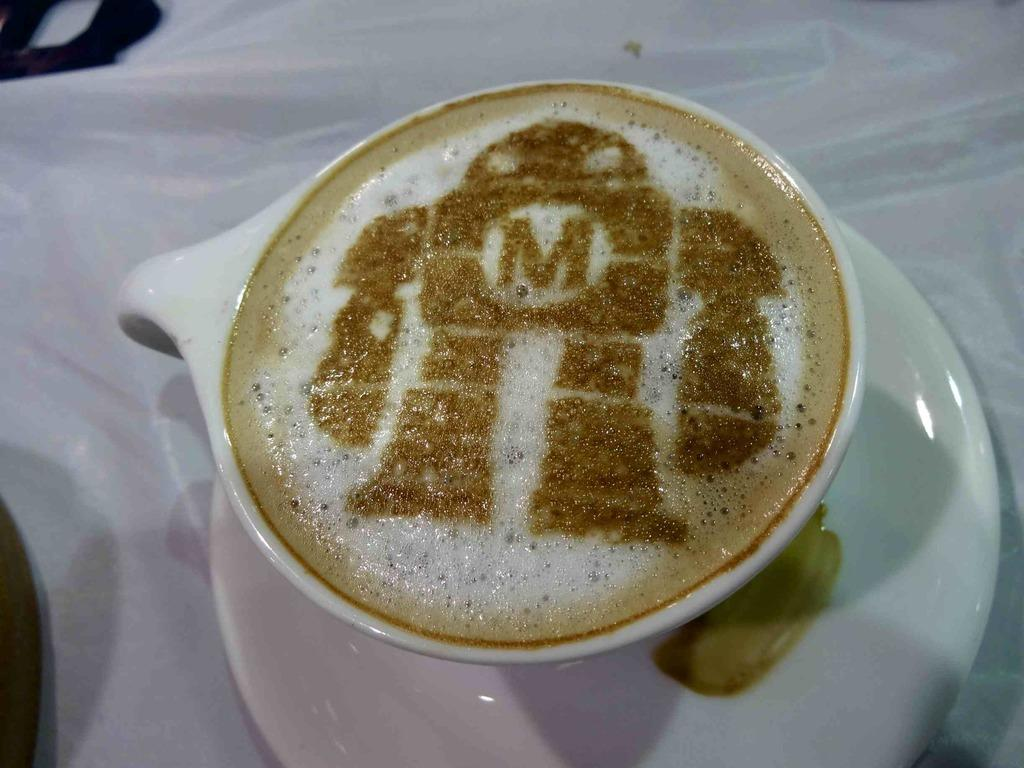What is the primary substance in the image? There is a liquid in the image. Can you describe the unique letter in the image? There is a letter in the shape of a person in a cup. What other objects can be seen in the image? There are other objects in the image. Who is the creator of the magic kittens in the image? There are no magic kittens present in the image, so it is not possible to determine who their creator might be. 